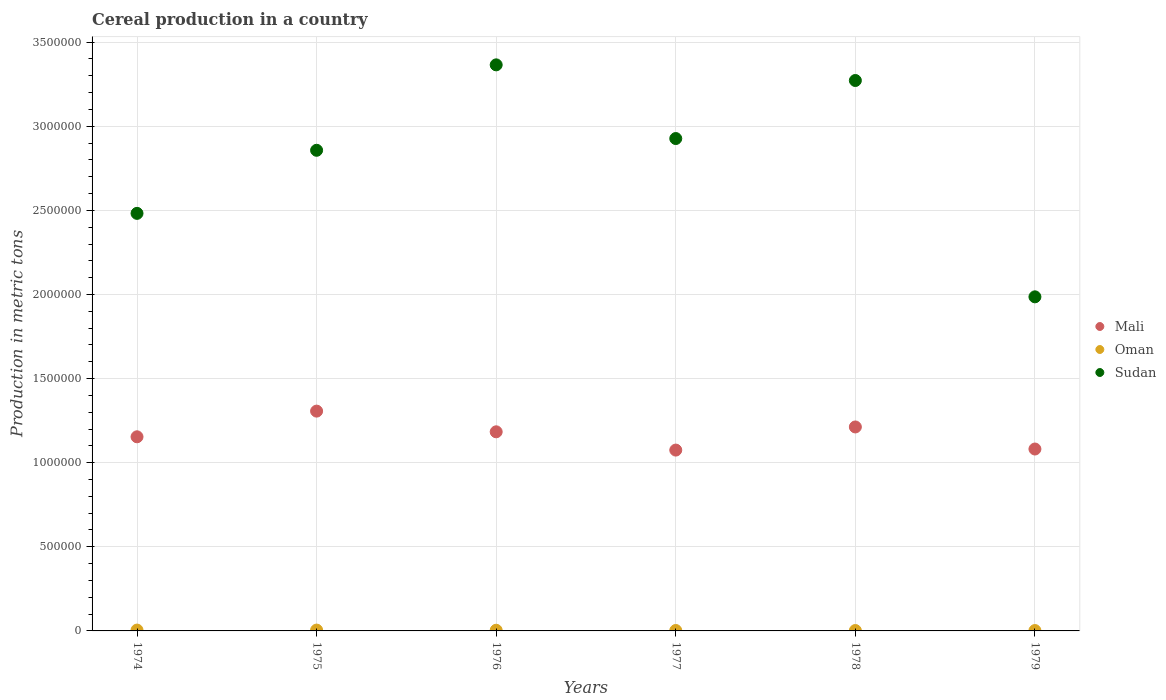What is the total cereal production in Sudan in 1977?
Keep it short and to the point. 2.93e+06. Across all years, what is the maximum total cereal production in Sudan?
Make the answer very short. 3.36e+06. Across all years, what is the minimum total cereal production in Oman?
Make the answer very short. 2250. In which year was the total cereal production in Mali maximum?
Your answer should be very brief. 1975. In which year was the total cereal production in Mali minimum?
Make the answer very short. 1977. What is the total total cereal production in Mali in the graph?
Make the answer very short. 7.01e+06. What is the difference between the total cereal production in Sudan in 1976 and that in 1979?
Provide a succinct answer. 1.38e+06. What is the difference between the total cereal production in Oman in 1979 and the total cereal production in Mali in 1975?
Give a very brief answer. -1.30e+06. What is the average total cereal production in Oman per year?
Keep it short and to the point. 3537.5. In the year 1976, what is the difference between the total cereal production in Oman and total cereal production in Mali?
Provide a succinct answer. -1.18e+06. In how many years, is the total cereal production in Sudan greater than 1200000 metric tons?
Give a very brief answer. 6. What is the ratio of the total cereal production in Sudan in 1975 to that in 1976?
Ensure brevity in your answer.  0.85. Is the total cereal production in Sudan in 1974 less than that in 1977?
Offer a very short reply. Yes. What is the difference between the highest and the second highest total cereal production in Sudan?
Keep it short and to the point. 9.30e+04. What is the difference between the highest and the lowest total cereal production in Mali?
Ensure brevity in your answer.  2.32e+05. In how many years, is the total cereal production in Mali greater than the average total cereal production in Mali taken over all years?
Offer a very short reply. 3. Is it the case that in every year, the sum of the total cereal production in Sudan and total cereal production in Oman  is greater than the total cereal production in Mali?
Provide a short and direct response. Yes. Does the total cereal production in Oman monotonically increase over the years?
Your response must be concise. No. Does the graph contain grids?
Make the answer very short. Yes. Where does the legend appear in the graph?
Provide a succinct answer. Center right. How many legend labels are there?
Your answer should be very brief. 3. What is the title of the graph?
Your answer should be compact. Cereal production in a country. Does "Syrian Arab Republic" appear as one of the legend labels in the graph?
Provide a succinct answer. No. What is the label or title of the Y-axis?
Make the answer very short. Production in metric tons. What is the Production in metric tons in Mali in 1974?
Keep it short and to the point. 1.15e+06. What is the Production in metric tons of Sudan in 1974?
Offer a terse response. 2.48e+06. What is the Production in metric tons of Mali in 1975?
Offer a very short reply. 1.31e+06. What is the Production in metric tons of Sudan in 1975?
Offer a terse response. 2.86e+06. What is the Production in metric tons in Mali in 1976?
Provide a short and direct response. 1.18e+06. What is the Production in metric tons of Oman in 1976?
Give a very brief answer. 4000. What is the Production in metric tons of Sudan in 1976?
Make the answer very short. 3.36e+06. What is the Production in metric tons in Mali in 1977?
Provide a short and direct response. 1.08e+06. What is the Production in metric tons in Oman in 1977?
Your answer should be compact. 2600. What is the Production in metric tons in Sudan in 1977?
Your answer should be very brief. 2.93e+06. What is the Production in metric tons in Mali in 1978?
Provide a short and direct response. 1.21e+06. What is the Production in metric tons in Oman in 1978?
Your answer should be compact. 2375. What is the Production in metric tons in Sudan in 1978?
Your response must be concise. 3.27e+06. What is the Production in metric tons of Mali in 1979?
Provide a succinct answer. 1.08e+06. What is the Production in metric tons in Oman in 1979?
Provide a succinct answer. 2250. What is the Production in metric tons of Sudan in 1979?
Your response must be concise. 1.99e+06. Across all years, what is the maximum Production in metric tons of Mali?
Keep it short and to the point. 1.31e+06. Across all years, what is the maximum Production in metric tons of Oman?
Offer a very short reply. 5000. Across all years, what is the maximum Production in metric tons in Sudan?
Provide a succinct answer. 3.36e+06. Across all years, what is the minimum Production in metric tons of Mali?
Your response must be concise. 1.08e+06. Across all years, what is the minimum Production in metric tons of Oman?
Give a very brief answer. 2250. Across all years, what is the minimum Production in metric tons in Sudan?
Your answer should be compact. 1.99e+06. What is the total Production in metric tons of Mali in the graph?
Offer a very short reply. 7.01e+06. What is the total Production in metric tons of Oman in the graph?
Your answer should be compact. 2.12e+04. What is the total Production in metric tons of Sudan in the graph?
Provide a succinct answer. 1.69e+07. What is the difference between the Production in metric tons in Mali in 1974 and that in 1975?
Your answer should be very brief. -1.53e+05. What is the difference between the Production in metric tons in Oman in 1974 and that in 1975?
Offer a terse response. 0. What is the difference between the Production in metric tons in Sudan in 1974 and that in 1975?
Keep it short and to the point. -3.75e+05. What is the difference between the Production in metric tons in Mali in 1974 and that in 1976?
Your answer should be very brief. -2.96e+04. What is the difference between the Production in metric tons of Sudan in 1974 and that in 1976?
Offer a terse response. -8.83e+05. What is the difference between the Production in metric tons of Mali in 1974 and that in 1977?
Your response must be concise. 7.90e+04. What is the difference between the Production in metric tons of Oman in 1974 and that in 1977?
Ensure brevity in your answer.  2400. What is the difference between the Production in metric tons of Sudan in 1974 and that in 1977?
Your answer should be very brief. -4.45e+05. What is the difference between the Production in metric tons of Mali in 1974 and that in 1978?
Your response must be concise. -5.85e+04. What is the difference between the Production in metric tons of Oman in 1974 and that in 1978?
Provide a short and direct response. 2625. What is the difference between the Production in metric tons in Sudan in 1974 and that in 1978?
Provide a short and direct response. -7.90e+05. What is the difference between the Production in metric tons in Mali in 1974 and that in 1979?
Offer a very short reply. 7.27e+04. What is the difference between the Production in metric tons of Oman in 1974 and that in 1979?
Your response must be concise. 2750. What is the difference between the Production in metric tons of Sudan in 1974 and that in 1979?
Offer a terse response. 4.96e+05. What is the difference between the Production in metric tons in Mali in 1975 and that in 1976?
Provide a succinct answer. 1.23e+05. What is the difference between the Production in metric tons of Sudan in 1975 and that in 1976?
Ensure brevity in your answer.  -5.08e+05. What is the difference between the Production in metric tons of Mali in 1975 and that in 1977?
Keep it short and to the point. 2.32e+05. What is the difference between the Production in metric tons of Oman in 1975 and that in 1977?
Offer a very short reply. 2400. What is the difference between the Production in metric tons in Sudan in 1975 and that in 1977?
Offer a very short reply. -6.98e+04. What is the difference between the Production in metric tons in Mali in 1975 and that in 1978?
Offer a terse response. 9.41e+04. What is the difference between the Production in metric tons of Oman in 1975 and that in 1978?
Your answer should be very brief. 2625. What is the difference between the Production in metric tons of Sudan in 1975 and that in 1978?
Provide a short and direct response. -4.15e+05. What is the difference between the Production in metric tons of Mali in 1975 and that in 1979?
Your answer should be very brief. 2.25e+05. What is the difference between the Production in metric tons in Oman in 1975 and that in 1979?
Make the answer very short. 2750. What is the difference between the Production in metric tons in Sudan in 1975 and that in 1979?
Your answer should be compact. 8.71e+05. What is the difference between the Production in metric tons in Mali in 1976 and that in 1977?
Provide a succinct answer. 1.09e+05. What is the difference between the Production in metric tons in Oman in 1976 and that in 1977?
Offer a terse response. 1400. What is the difference between the Production in metric tons in Sudan in 1976 and that in 1977?
Give a very brief answer. 4.38e+05. What is the difference between the Production in metric tons in Mali in 1976 and that in 1978?
Your answer should be compact. -2.89e+04. What is the difference between the Production in metric tons in Oman in 1976 and that in 1978?
Offer a terse response. 1625. What is the difference between the Production in metric tons in Sudan in 1976 and that in 1978?
Offer a terse response. 9.30e+04. What is the difference between the Production in metric tons in Mali in 1976 and that in 1979?
Offer a very short reply. 1.02e+05. What is the difference between the Production in metric tons of Oman in 1976 and that in 1979?
Your response must be concise. 1750. What is the difference between the Production in metric tons in Sudan in 1976 and that in 1979?
Give a very brief answer. 1.38e+06. What is the difference between the Production in metric tons in Mali in 1977 and that in 1978?
Your answer should be compact. -1.38e+05. What is the difference between the Production in metric tons in Oman in 1977 and that in 1978?
Give a very brief answer. 225. What is the difference between the Production in metric tons in Sudan in 1977 and that in 1978?
Offer a terse response. -3.45e+05. What is the difference between the Production in metric tons in Mali in 1977 and that in 1979?
Keep it short and to the point. -6330. What is the difference between the Production in metric tons of Oman in 1977 and that in 1979?
Offer a terse response. 350. What is the difference between the Production in metric tons of Sudan in 1977 and that in 1979?
Ensure brevity in your answer.  9.41e+05. What is the difference between the Production in metric tons in Mali in 1978 and that in 1979?
Your response must be concise. 1.31e+05. What is the difference between the Production in metric tons in Oman in 1978 and that in 1979?
Your answer should be compact. 125. What is the difference between the Production in metric tons of Sudan in 1978 and that in 1979?
Provide a succinct answer. 1.29e+06. What is the difference between the Production in metric tons of Mali in 1974 and the Production in metric tons of Oman in 1975?
Provide a short and direct response. 1.15e+06. What is the difference between the Production in metric tons in Mali in 1974 and the Production in metric tons in Sudan in 1975?
Ensure brevity in your answer.  -1.70e+06. What is the difference between the Production in metric tons in Oman in 1974 and the Production in metric tons in Sudan in 1975?
Keep it short and to the point. -2.85e+06. What is the difference between the Production in metric tons in Mali in 1974 and the Production in metric tons in Oman in 1976?
Your answer should be compact. 1.15e+06. What is the difference between the Production in metric tons in Mali in 1974 and the Production in metric tons in Sudan in 1976?
Give a very brief answer. -2.21e+06. What is the difference between the Production in metric tons in Oman in 1974 and the Production in metric tons in Sudan in 1976?
Give a very brief answer. -3.36e+06. What is the difference between the Production in metric tons of Mali in 1974 and the Production in metric tons of Oman in 1977?
Offer a very short reply. 1.15e+06. What is the difference between the Production in metric tons of Mali in 1974 and the Production in metric tons of Sudan in 1977?
Keep it short and to the point. -1.77e+06. What is the difference between the Production in metric tons in Oman in 1974 and the Production in metric tons in Sudan in 1977?
Offer a very short reply. -2.92e+06. What is the difference between the Production in metric tons of Mali in 1974 and the Production in metric tons of Oman in 1978?
Your answer should be compact. 1.15e+06. What is the difference between the Production in metric tons in Mali in 1974 and the Production in metric tons in Sudan in 1978?
Give a very brief answer. -2.12e+06. What is the difference between the Production in metric tons in Oman in 1974 and the Production in metric tons in Sudan in 1978?
Keep it short and to the point. -3.27e+06. What is the difference between the Production in metric tons of Mali in 1974 and the Production in metric tons of Oman in 1979?
Ensure brevity in your answer.  1.15e+06. What is the difference between the Production in metric tons in Mali in 1974 and the Production in metric tons in Sudan in 1979?
Your answer should be compact. -8.32e+05. What is the difference between the Production in metric tons of Oman in 1974 and the Production in metric tons of Sudan in 1979?
Ensure brevity in your answer.  -1.98e+06. What is the difference between the Production in metric tons in Mali in 1975 and the Production in metric tons in Oman in 1976?
Offer a very short reply. 1.30e+06. What is the difference between the Production in metric tons of Mali in 1975 and the Production in metric tons of Sudan in 1976?
Ensure brevity in your answer.  -2.06e+06. What is the difference between the Production in metric tons in Oman in 1975 and the Production in metric tons in Sudan in 1976?
Keep it short and to the point. -3.36e+06. What is the difference between the Production in metric tons in Mali in 1975 and the Production in metric tons in Oman in 1977?
Provide a succinct answer. 1.30e+06. What is the difference between the Production in metric tons of Mali in 1975 and the Production in metric tons of Sudan in 1977?
Provide a short and direct response. -1.62e+06. What is the difference between the Production in metric tons of Oman in 1975 and the Production in metric tons of Sudan in 1977?
Make the answer very short. -2.92e+06. What is the difference between the Production in metric tons in Mali in 1975 and the Production in metric tons in Oman in 1978?
Offer a terse response. 1.30e+06. What is the difference between the Production in metric tons of Mali in 1975 and the Production in metric tons of Sudan in 1978?
Make the answer very short. -1.97e+06. What is the difference between the Production in metric tons in Oman in 1975 and the Production in metric tons in Sudan in 1978?
Offer a very short reply. -3.27e+06. What is the difference between the Production in metric tons of Mali in 1975 and the Production in metric tons of Oman in 1979?
Keep it short and to the point. 1.30e+06. What is the difference between the Production in metric tons of Mali in 1975 and the Production in metric tons of Sudan in 1979?
Make the answer very short. -6.79e+05. What is the difference between the Production in metric tons in Oman in 1975 and the Production in metric tons in Sudan in 1979?
Provide a succinct answer. -1.98e+06. What is the difference between the Production in metric tons of Mali in 1976 and the Production in metric tons of Oman in 1977?
Your response must be concise. 1.18e+06. What is the difference between the Production in metric tons in Mali in 1976 and the Production in metric tons in Sudan in 1977?
Your answer should be very brief. -1.74e+06. What is the difference between the Production in metric tons in Oman in 1976 and the Production in metric tons in Sudan in 1977?
Offer a very short reply. -2.92e+06. What is the difference between the Production in metric tons in Mali in 1976 and the Production in metric tons in Oman in 1978?
Provide a succinct answer. 1.18e+06. What is the difference between the Production in metric tons in Mali in 1976 and the Production in metric tons in Sudan in 1978?
Offer a very short reply. -2.09e+06. What is the difference between the Production in metric tons in Oman in 1976 and the Production in metric tons in Sudan in 1978?
Give a very brief answer. -3.27e+06. What is the difference between the Production in metric tons in Mali in 1976 and the Production in metric tons in Oman in 1979?
Your response must be concise. 1.18e+06. What is the difference between the Production in metric tons of Mali in 1976 and the Production in metric tons of Sudan in 1979?
Your answer should be very brief. -8.02e+05. What is the difference between the Production in metric tons of Oman in 1976 and the Production in metric tons of Sudan in 1979?
Provide a succinct answer. -1.98e+06. What is the difference between the Production in metric tons in Mali in 1977 and the Production in metric tons in Oman in 1978?
Your answer should be compact. 1.07e+06. What is the difference between the Production in metric tons of Mali in 1977 and the Production in metric tons of Sudan in 1978?
Your answer should be very brief. -2.20e+06. What is the difference between the Production in metric tons in Oman in 1977 and the Production in metric tons in Sudan in 1978?
Make the answer very short. -3.27e+06. What is the difference between the Production in metric tons of Mali in 1977 and the Production in metric tons of Oman in 1979?
Offer a very short reply. 1.07e+06. What is the difference between the Production in metric tons in Mali in 1977 and the Production in metric tons in Sudan in 1979?
Give a very brief answer. -9.11e+05. What is the difference between the Production in metric tons in Oman in 1977 and the Production in metric tons in Sudan in 1979?
Keep it short and to the point. -1.98e+06. What is the difference between the Production in metric tons of Mali in 1978 and the Production in metric tons of Oman in 1979?
Your answer should be compact. 1.21e+06. What is the difference between the Production in metric tons in Mali in 1978 and the Production in metric tons in Sudan in 1979?
Give a very brief answer. -7.73e+05. What is the difference between the Production in metric tons of Oman in 1978 and the Production in metric tons of Sudan in 1979?
Keep it short and to the point. -1.98e+06. What is the average Production in metric tons of Mali per year?
Provide a succinct answer. 1.17e+06. What is the average Production in metric tons of Oman per year?
Offer a terse response. 3537.5. What is the average Production in metric tons in Sudan per year?
Your answer should be very brief. 2.81e+06. In the year 1974, what is the difference between the Production in metric tons in Mali and Production in metric tons in Oman?
Ensure brevity in your answer.  1.15e+06. In the year 1974, what is the difference between the Production in metric tons of Mali and Production in metric tons of Sudan?
Provide a succinct answer. -1.33e+06. In the year 1974, what is the difference between the Production in metric tons in Oman and Production in metric tons in Sudan?
Keep it short and to the point. -2.48e+06. In the year 1975, what is the difference between the Production in metric tons of Mali and Production in metric tons of Oman?
Give a very brief answer. 1.30e+06. In the year 1975, what is the difference between the Production in metric tons in Mali and Production in metric tons in Sudan?
Keep it short and to the point. -1.55e+06. In the year 1975, what is the difference between the Production in metric tons of Oman and Production in metric tons of Sudan?
Provide a short and direct response. -2.85e+06. In the year 1976, what is the difference between the Production in metric tons of Mali and Production in metric tons of Oman?
Ensure brevity in your answer.  1.18e+06. In the year 1976, what is the difference between the Production in metric tons of Mali and Production in metric tons of Sudan?
Make the answer very short. -2.18e+06. In the year 1976, what is the difference between the Production in metric tons of Oman and Production in metric tons of Sudan?
Offer a very short reply. -3.36e+06. In the year 1977, what is the difference between the Production in metric tons of Mali and Production in metric tons of Oman?
Your response must be concise. 1.07e+06. In the year 1977, what is the difference between the Production in metric tons in Mali and Production in metric tons in Sudan?
Your response must be concise. -1.85e+06. In the year 1977, what is the difference between the Production in metric tons in Oman and Production in metric tons in Sudan?
Ensure brevity in your answer.  -2.92e+06. In the year 1978, what is the difference between the Production in metric tons of Mali and Production in metric tons of Oman?
Make the answer very short. 1.21e+06. In the year 1978, what is the difference between the Production in metric tons of Mali and Production in metric tons of Sudan?
Provide a short and direct response. -2.06e+06. In the year 1978, what is the difference between the Production in metric tons in Oman and Production in metric tons in Sudan?
Offer a very short reply. -3.27e+06. In the year 1979, what is the difference between the Production in metric tons in Mali and Production in metric tons in Oman?
Provide a short and direct response. 1.08e+06. In the year 1979, what is the difference between the Production in metric tons of Mali and Production in metric tons of Sudan?
Provide a succinct answer. -9.05e+05. In the year 1979, what is the difference between the Production in metric tons in Oman and Production in metric tons in Sudan?
Your answer should be compact. -1.98e+06. What is the ratio of the Production in metric tons of Mali in 1974 to that in 1975?
Give a very brief answer. 0.88. What is the ratio of the Production in metric tons in Sudan in 1974 to that in 1975?
Keep it short and to the point. 0.87. What is the ratio of the Production in metric tons of Mali in 1974 to that in 1976?
Offer a very short reply. 0.97. What is the ratio of the Production in metric tons of Sudan in 1974 to that in 1976?
Your response must be concise. 0.74. What is the ratio of the Production in metric tons of Mali in 1974 to that in 1977?
Offer a terse response. 1.07. What is the ratio of the Production in metric tons in Oman in 1974 to that in 1977?
Your answer should be very brief. 1.92. What is the ratio of the Production in metric tons of Sudan in 1974 to that in 1977?
Your answer should be very brief. 0.85. What is the ratio of the Production in metric tons in Mali in 1974 to that in 1978?
Give a very brief answer. 0.95. What is the ratio of the Production in metric tons of Oman in 1974 to that in 1978?
Your response must be concise. 2.11. What is the ratio of the Production in metric tons in Sudan in 1974 to that in 1978?
Keep it short and to the point. 0.76. What is the ratio of the Production in metric tons of Mali in 1974 to that in 1979?
Provide a short and direct response. 1.07. What is the ratio of the Production in metric tons in Oman in 1974 to that in 1979?
Your response must be concise. 2.22. What is the ratio of the Production in metric tons of Sudan in 1974 to that in 1979?
Your answer should be very brief. 1.25. What is the ratio of the Production in metric tons of Mali in 1975 to that in 1976?
Provide a succinct answer. 1.1. What is the ratio of the Production in metric tons of Oman in 1975 to that in 1976?
Keep it short and to the point. 1.25. What is the ratio of the Production in metric tons in Sudan in 1975 to that in 1976?
Your response must be concise. 0.85. What is the ratio of the Production in metric tons of Mali in 1975 to that in 1977?
Your answer should be very brief. 1.22. What is the ratio of the Production in metric tons in Oman in 1975 to that in 1977?
Make the answer very short. 1.92. What is the ratio of the Production in metric tons in Sudan in 1975 to that in 1977?
Keep it short and to the point. 0.98. What is the ratio of the Production in metric tons in Mali in 1975 to that in 1978?
Your answer should be compact. 1.08. What is the ratio of the Production in metric tons in Oman in 1975 to that in 1978?
Make the answer very short. 2.11. What is the ratio of the Production in metric tons in Sudan in 1975 to that in 1978?
Your answer should be very brief. 0.87. What is the ratio of the Production in metric tons in Mali in 1975 to that in 1979?
Your answer should be very brief. 1.21. What is the ratio of the Production in metric tons in Oman in 1975 to that in 1979?
Ensure brevity in your answer.  2.22. What is the ratio of the Production in metric tons of Sudan in 1975 to that in 1979?
Keep it short and to the point. 1.44. What is the ratio of the Production in metric tons of Mali in 1976 to that in 1977?
Make the answer very short. 1.1. What is the ratio of the Production in metric tons in Oman in 1976 to that in 1977?
Your answer should be compact. 1.54. What is the ratio of the Production in metric tons in Sudan in 1976 to that in 1977?
Provide a succinct answer. 1.15. What is the ratio of the Production in metric tons in Mali in 1976 to that in 1978?
Make the answer very short. 0.98. What is the ratio of the Production in metric tons of Oman in 1976 to that in 1978?
Your response must be concise. 1.68. What is the ratio of the Production in metric tons of Sudan in 1976 to that in 1978?
Your response must be concise. 1.03. What is the ratio of the Production in metric tons of Mali in 1976 to that in 1979?
Your response must be concise. 1.09. What is the ratio of the Production in metric tons of Oman in 1976 to that in 1979?
Keep it short and to the point. 1.78. What is the ratio of the Production in metric tons of Sudan in 1976 to that in 1979?
Provide a short and direct response. 1.69. What is the ratio of the Production in metric tons of Mali in 1977 to that in 1978?
Ensure brevity in your answer.  0.89. What is the ratio of the Production in metric tons of Oman in 1977 to that in 1978?
Provide a short and direct response. 1.09. What is the ratio of the Production in metric tons in Sudan in 1977 to that in 1978?
Your answer should be very brief. 0.89. What is the ratio of the Production in metric tons of Mali in 1977 to that in 1979?
Offer a terse response. 0.99. What is the ratio of the Production in metric tons in Oman in 1977 to that in 1979?
Your answer should be compact. 1.16. What is the ratio of the Production in metric tons in Sudan in 1977 to that in 1979?
Provide a succinct answer. 1.47. What is the ratio of the Production in metric tons in Mali in 1978 to that in 1979?
Ensure brevity in your answer.  1.12. What is the ratio of the Production in metric tons in Oman in 1978 to that in 1979?
Your answer should be compact. 1.06. What is the ratio of the Production in metric tons of Sudan in 1978 to that in 1979?
Offer a very short reply. 1.65. What is the difference between the highest and the second highest Production in metric tons of Mali?
Your answer should be compact. 9.41e+04. What is the difference between the highest and the second highest Production in metric tons of Sudan?
Provide a short and direct response. 9.30e+04. What is the difference between the highest and the lowest Production in metric tons of Mali?
Your answer should be compact. 2.32e+05. What is the difference between the highest and the lowest Production in metric tons in Oman?
Ensure brevity in your answer.  2750. What is the difference between the highest and the lowest Production in metric tons of Sudan?
Make the answer very short. 1.38e+06. 